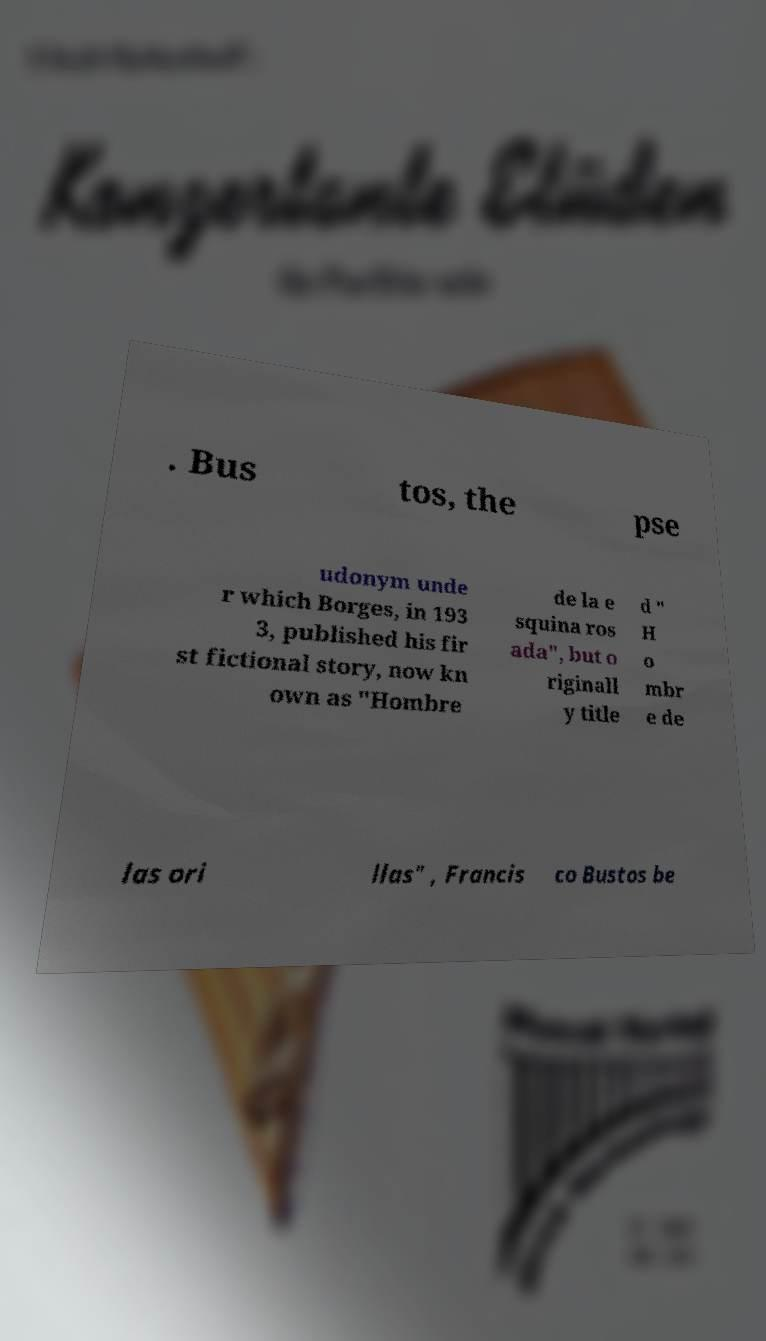Could you extract and type out the text from this image? . Bus tos, the pse udonym unde r which Borges, in 193 3, published his fir st fictional story, now kn own as "Hombre de la e squina ros ada", but o riginall y title d " H o mbr e de las ori llas" , Francis co Bustos be 